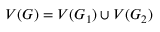<formula> <loc_0><loc_0><loc_500><loc_500>V ( G ) = V ( G _ { 1 } ) \cup V ( G _ { 2 } )</formula> 